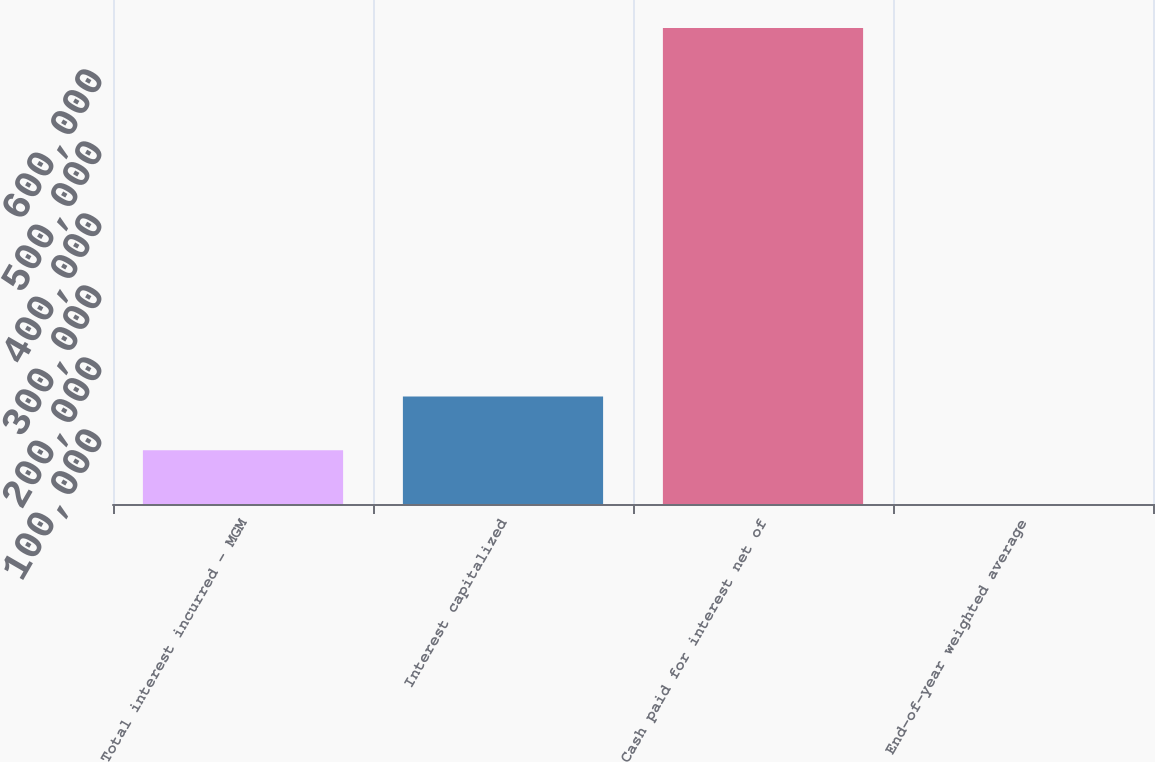Convert chart to OTSL. <chart><loc_0><loc_0><loc_500><loc_500><bar_chart><fcel>Total interest incurred - MGM<fcel>Interest capitalized<fcel>Cash paid for interest net of<fcel>End-of-year weighted average<nl><fcel>74651.6<fcel>149298<fcel>661166<fcel>5.4<nl></chart> 